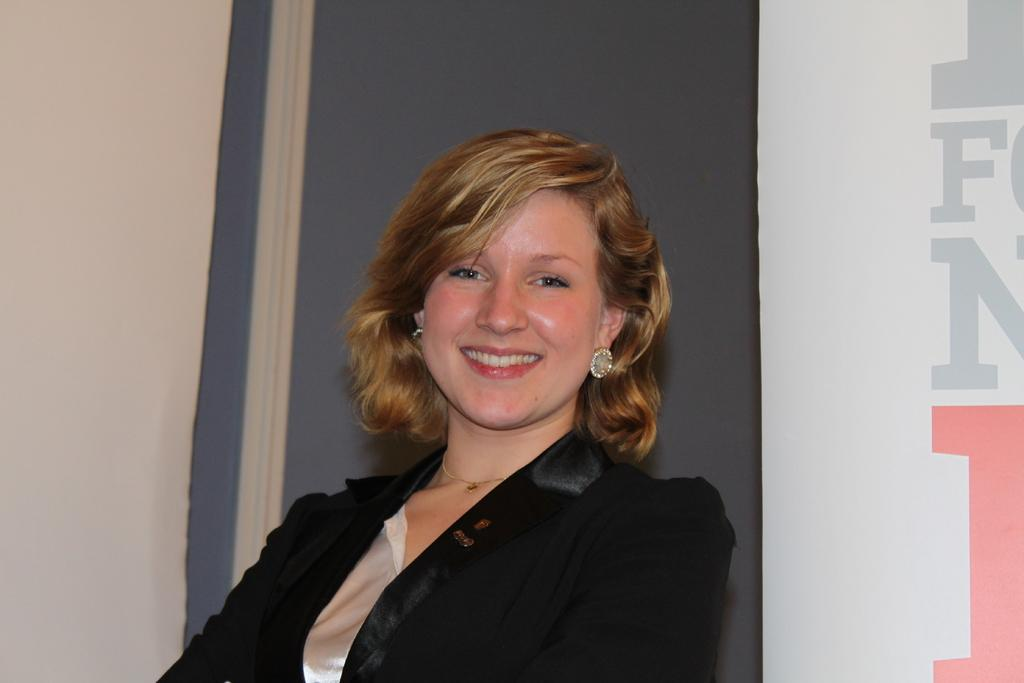Who is present in the image? There is a woman in the image. What is the woman's expression? The woman is smiling. What can be seen in the background of the image? There is a wall and a banner in the background of the image. What type of glue is the woman using to attach the parcel to the car in the image? There is no car, glue, or parcel present in the image. 